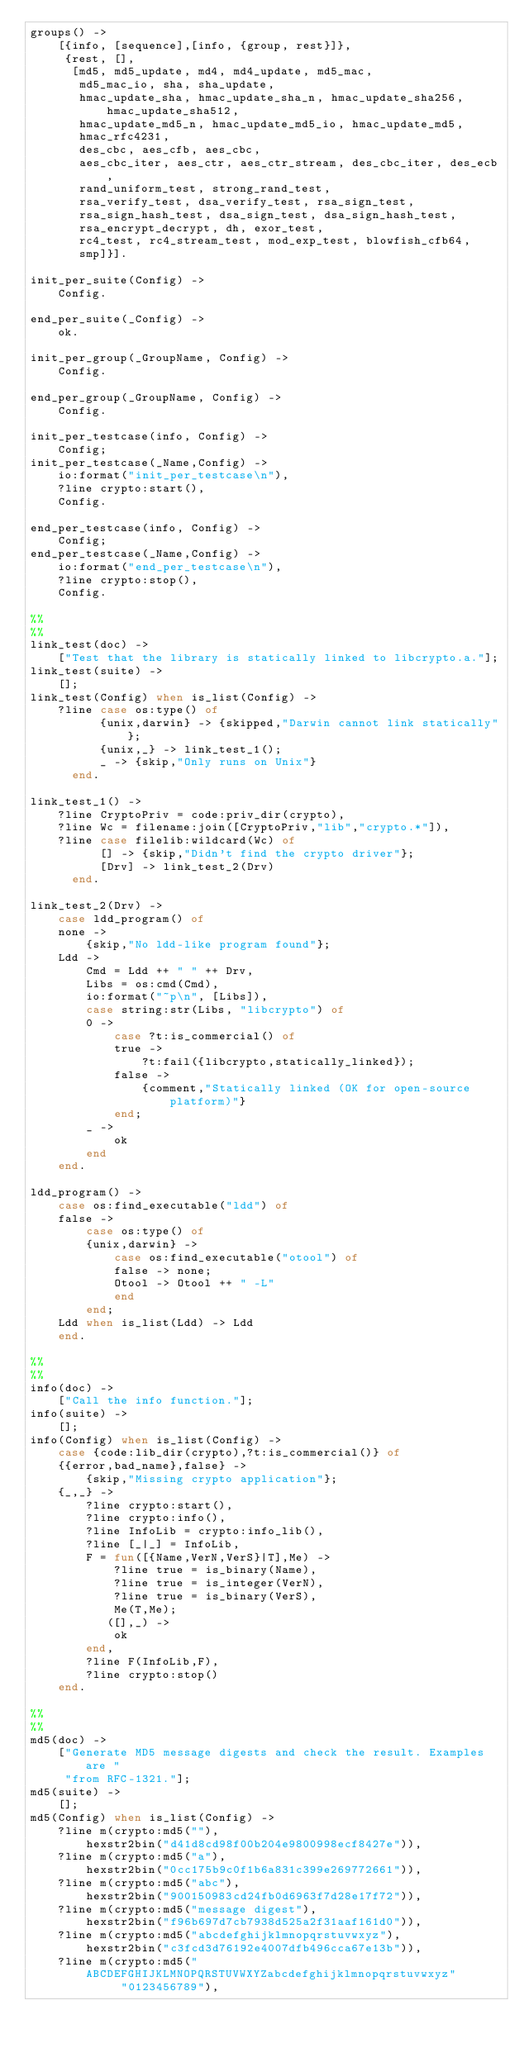<code> <loc_0><loc_0><loc_500><loc_500><_Erlang_>groups() ->
    [{info, [sequence],[info, {group, rest}]},
     {rest, [],
      [md5, md5_update, md4, md4_update, md5_mac,
       md5_mac_io, sha, sha_update,
       hmac_update_sha, hmac_update_sha_n, hmac_update_sha256, hmac_update_sha512,
       hmac_update_md5_n, hmac_update_md5_io, hmac_update_md5,
       hmac_rfc4231,
       des_cbc, aes_cfb, aes_cbc,
       aes_cbc_iter, aes_ctr, aes_ctr_stream, des_cbc_iter, des_ecb,
       rand_uniform_test, strong_rand_test,
       rsa_verify_test, dsa_verify_test, rsa_sign_test,
       rsa_sign_hash_test, dsa_sign_test, dsa_sign_hash_test,
       rsa_encrypt_decrypt, dh, exor_test,
       rc4_test, rc4_stream_test, mod_exp_test, blowfish_cfb64,
       smp]}].

init_per_suite(Config) ->
    Config.

end_per_suite(_Config) ->
    ok.

init_per_group(_GroupName, Config) ->
    Config.

end_per_group(_GroupName, Config) ->
    Config.

init_per_testcase(info, Config) ->
    Config;
init_per_testcase(_Name,Config) ->
    io:format("init_per_testcase\n"),
    ?line crypto:start(),
    Config.

end_per_testcase(info, Config) ->
    Config;
end_per_testcase(_Name,Config) ->
    io:format("end_per_testcase\n"),
    ?line crypto:stop(),
    Config.

%%
%%
link_test(doc) ->
    ["Test that the library is statically linked to libcrypto.a."];
link_test(suite) ->
    [];
link_test(Config) when is_list(Config) ->
    ?line case os:type() of
	      {unix,darwin} -> {skipped,"Darwin cannot link statically"};
	      {unix,_} -> link_test_1();
	      _ -> {skip,"Only runs on Unix"}
	  end.

link_test_1() ->    
    ?line CryptoPriv = code:priv_dir(crypto),
    ?line Wc = filename:join([CryptoPriv,"lib","crypto.*"]),
    ?line case filelib:wildcard(Wc) of
	      [] -> {skip,"Didn't find the crypto driver"};
	      [Drv] -> link_test_2(Drv)
	  end.

link_test_2(Drv) ->
    case ldd_program() of
	none ->
	    {skip,"No ldd-like program found"};
	Ldd ->
	    Cmd = Ldd ++ " " ++ Drv,
	    Libs = os:cmd(Cmd),
	    io:format("~p\n", [Libs]),
	    case string:str(Libs, "libcrypto") of
		0 -> 
		    case ?t:is_commercial() of
			true ->
			    ?t:fail({libcrypto,statically_linked});
			false ->
			    {comment,"Statically linked (OK for open-source platform)"}
		    end;
		_ ->
		    ok
	    end
    end.

ldd_program() ->
    case os:find_executable("ldd") of
	false ->
	    case os:type() of
		{unix,darwin} ->
		    case os:find_executable("otool") of
			false -> none;
			Otool -> Otool ++ " -L"
		    end
	    end;
 	Ldd when is_list(Ldd) -> Ldd
    end.

%%
%%
info(doc) ->
    ["Call the info function."];
info(suite) ->
    [];
info(Config) when is_list(Config) ->
    case {code:lib_dir(crypto),?t:is_commercial()} of
	{{error,bad_name},false} ->
	    {skip,"Missing crypto application"};
	{_,_} ->
	    ?line crypto:start(),
	    ?line crypto:info(),
	    ?line InfoLib = crypto:info_lib(),
	    ?line [_|_] = InfoLib,
	    F = fun([{Name,VerN,VerS}|T],Me) ->
			?line true = is_binary(Name),
			?line true = is_integer(VerN),
			?line true = is_binary(VerS),
			Me(T,Me);
		   ([],_) ->
			ok
		end,	    
	    ?line F(InfoLib,F),
	    ?line crypto:stop()
    end.

%%
%%
md5(doc) ->
    ["Generate MD5 message digests and check the result. Examples are "
     "from RFC-1321."];
md5(suite) ->
    [];
md5(Config) when is_list(Config) ->
    ?line m(crypto:md5(""), 
		hexstr2bin("d41d8cd98f00b204e9800998ecf8427e")),
    ?line m(crypto:md5("a"), 
		hexstr2bin("0cc175b9c0f1b6a831c399e269772661")),
    ?line m(crypto:md5("abc"), 
		hexstr2bin("900150983cd24fb0d6963f7d28e17f72")),
    ?line m(crypto:md5("message digest"),
		hexstr2bin("f96b697d7cb7938d525a2f31aaf161d0")),
    ?line m(crypto:md5("abcdefghijklmnopqrstuvwxyz"),
	    hexstr2bin("c3fcd3d76192e4007dfb496cca67e13b")),
    ?line m(crypto:md5("ABCDEFGHIJKLMNOPQRSTUVWXYZabcdefghijklmnopqrstuvwxyz"
		     "0123456789"),  </code> 